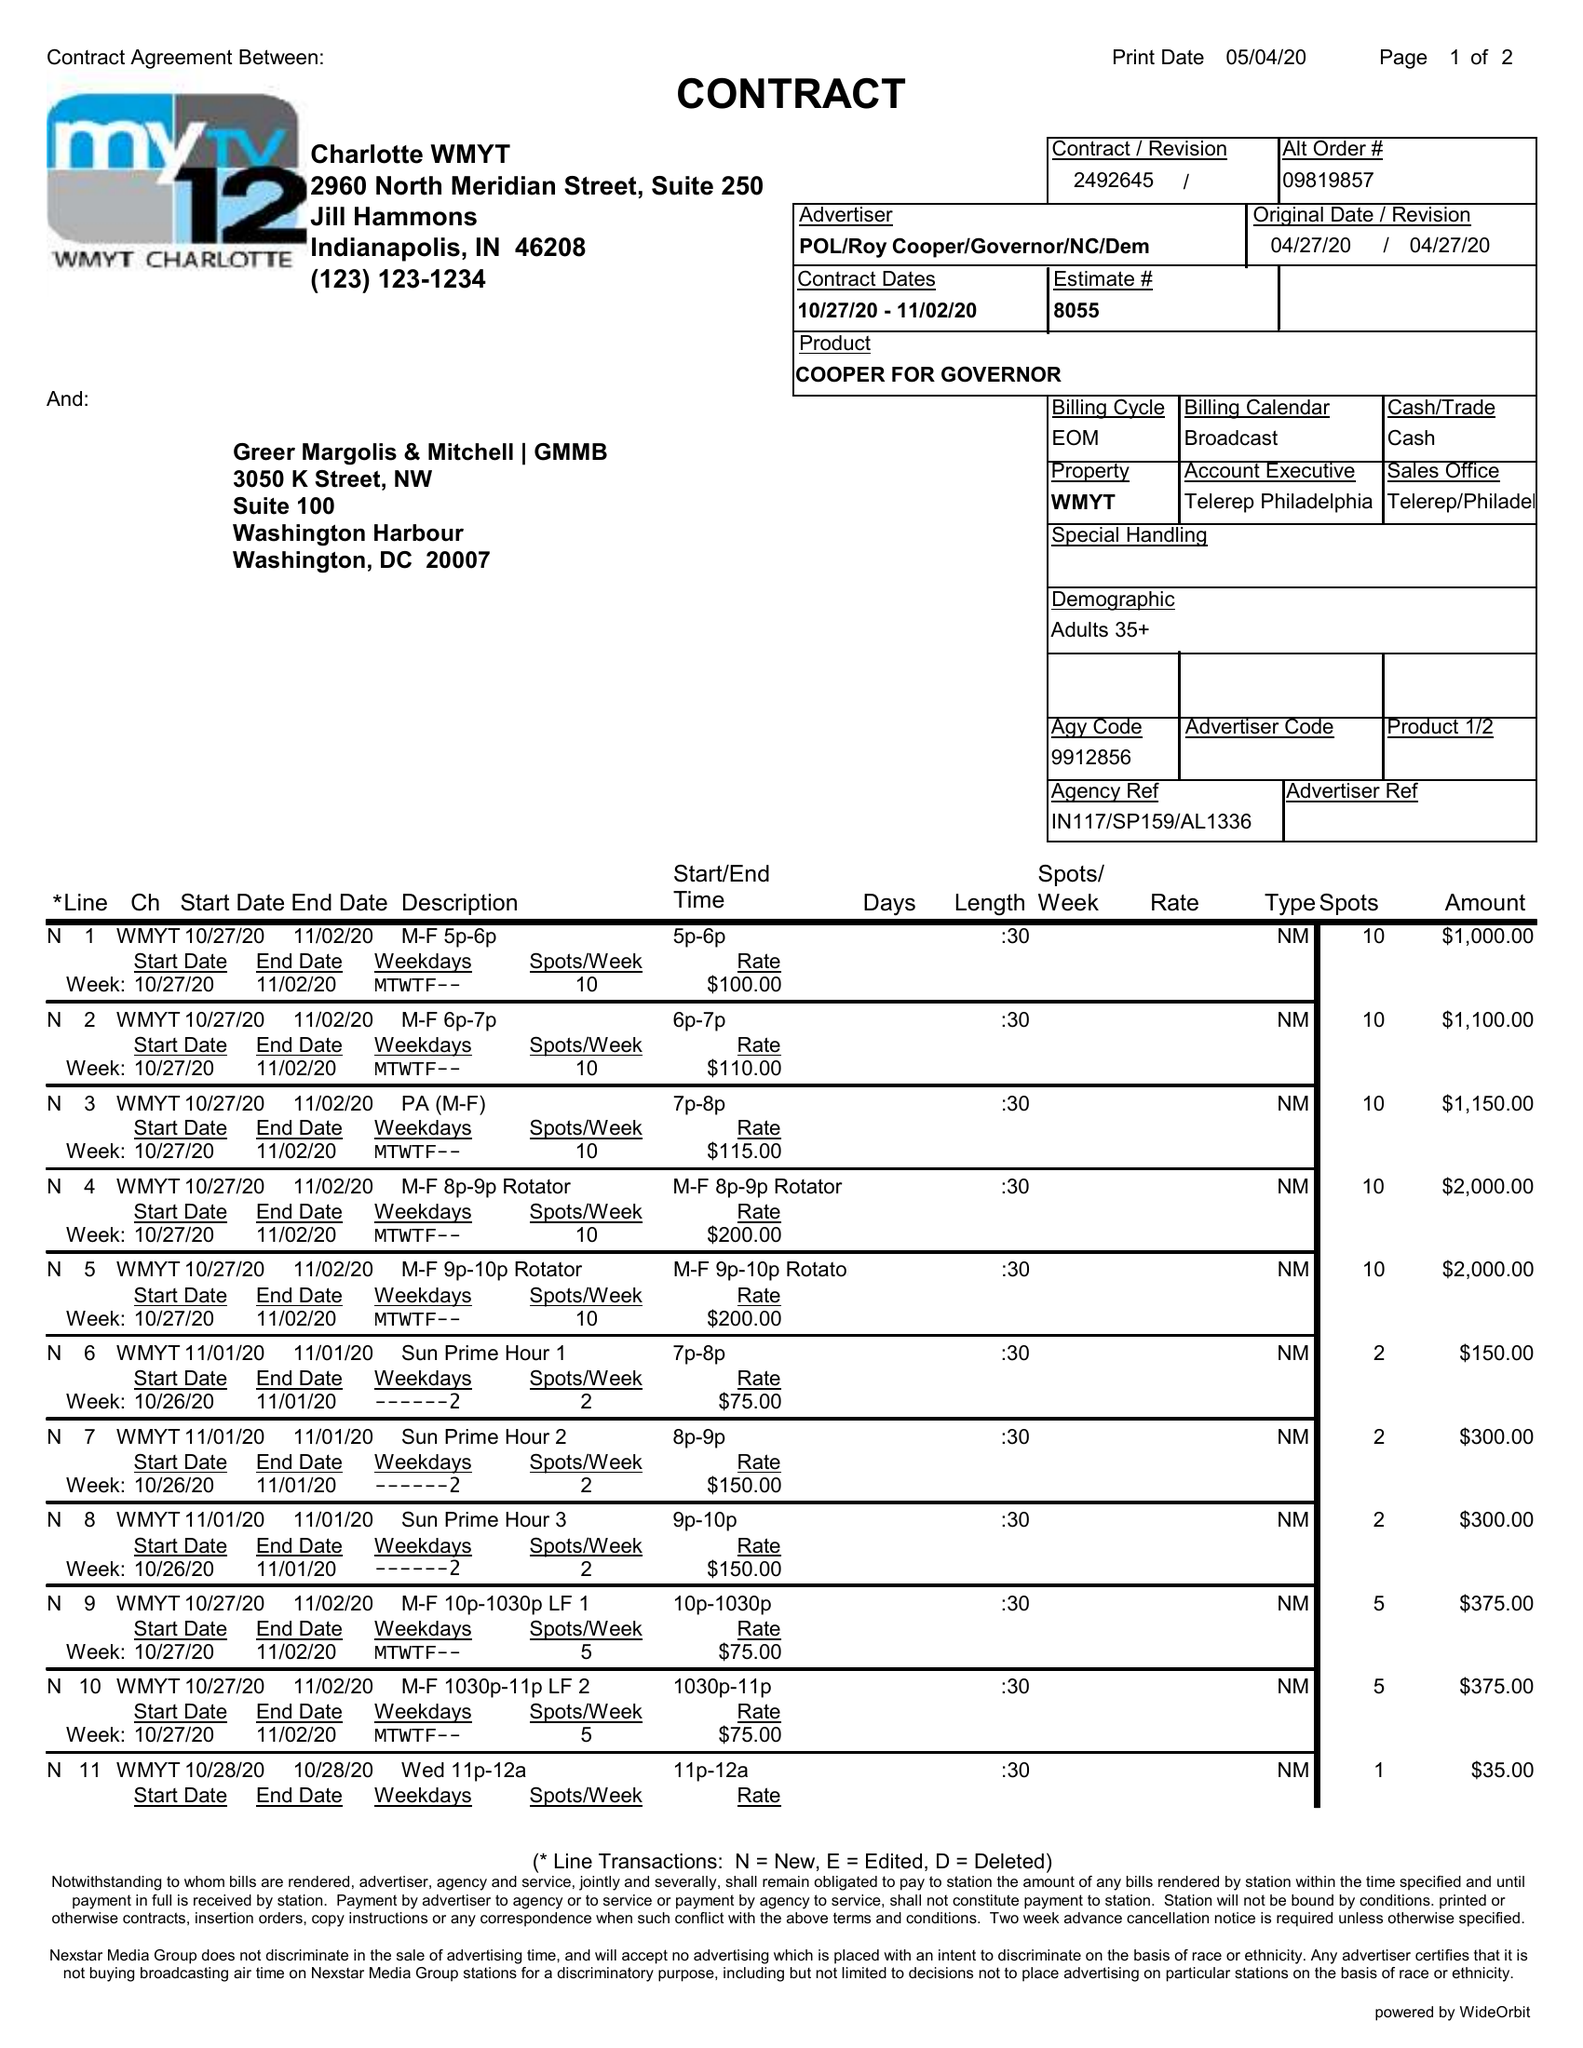What is the value for the gross_amount?
Answer the question using a single word or phrase. 9260.00 